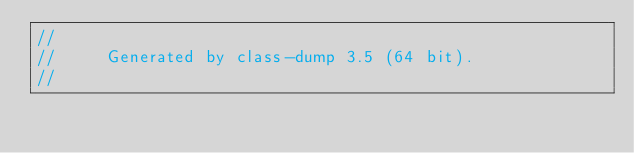Convert code to text. <code><loc_0><loc_0><loc_500><loc_500><_C_>//
//     Generated by class-dump 3.5 (64 bit).
//</code> 